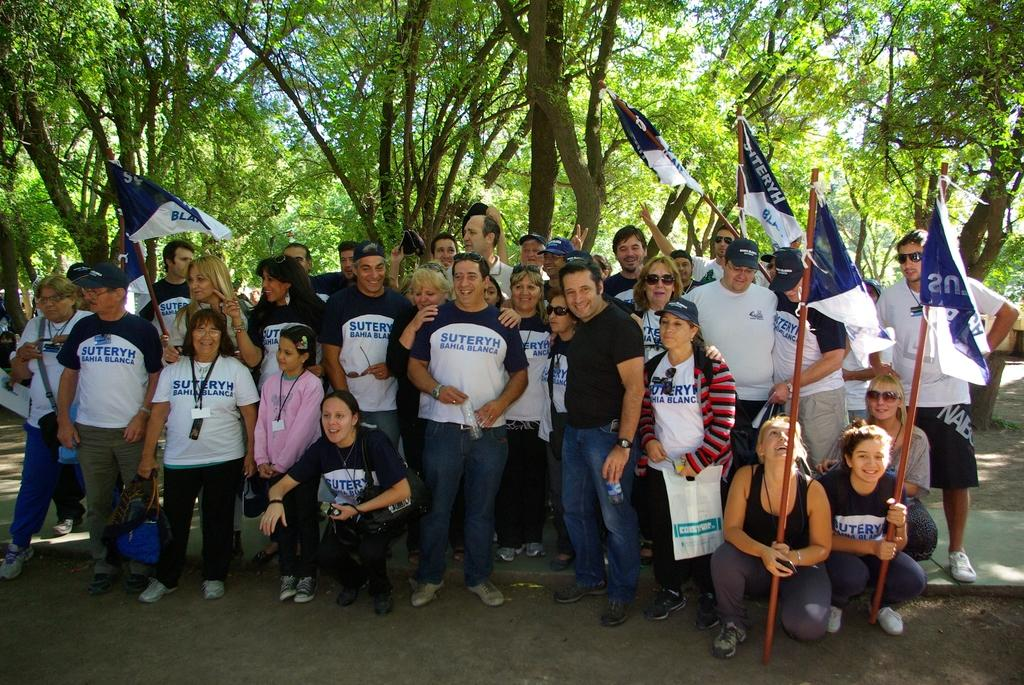What are the people in the image doing? The people in the image are standing and holding flags. Are there any other individuals in the image besides the group of people standing? Yes, there are four women sitting in front of the group. What can be seen in the background of the image? There are trees in the background of the image. What type of voice can be heard coming from the trees in the background? There is no voice or sound present in the image, as it is a still photograph. 